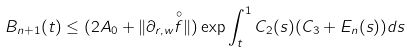Convert formula to latex. <formula><loc_0><loc_0><loc_500><loc_500>B _ { n + 1 } ( t ) \leq ( 2 A _ { 0 } + \| \partial _ { r , w } \overset { \circ } { f } \| ) \exp \int _ { t } ^ { 1 } C _ { 2 } ( s ) ( C _ { 3 } + E _ { n } ( s ) ) d s</formula> 